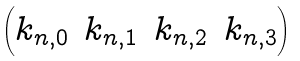Convert formula to latex. <formula><loc_0><loc_0><loc_500><loc_500>\begin{pmatrix} k _ { n , 0 } & k _ { n , 1 } & k _ { n , 2 } & k _ { n , 3 } \end{pmatrix}</formula> 